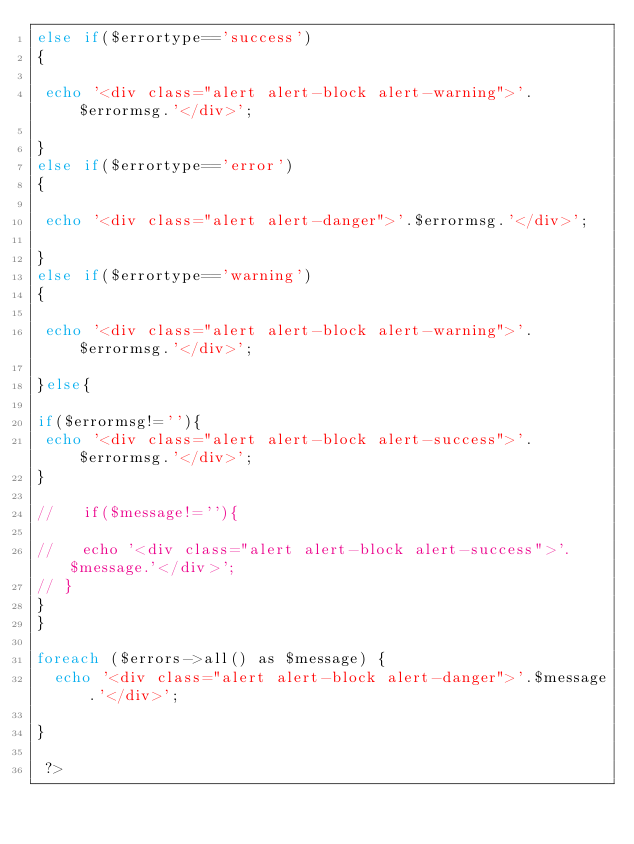Convert code to text. <code><loc_0><loc_0><loc_500><loc_500><_PHP_>else if($errortype=='success')
{
   
 echo '<div class="alert alert-block alert-warning">'.$errormsg.'</div>';

}
else if($errortype=='error')
{

 echo '<div class="alert alert-danger">'.$errormsg.'</div>';

}
else if($errortype=='warning')
{

 echo '<div class="alert alert-block alert-warning">'.$errormsg.'</div>';

}else{

if($errormsg!=''){
 echo '<div class="alert alert-block alert-success">'.$errormsg.'</div>';
}

//   if($message!=''){
  
//   echo '<div class="alert alert-block alert-success">'.$message.'</div>';
// }
}
}

foreach ($errors->all() as $message) {
  echo '<div class="alert alert-block alert-danger">'.$message.'</div>';
   
}

 ?></code> 